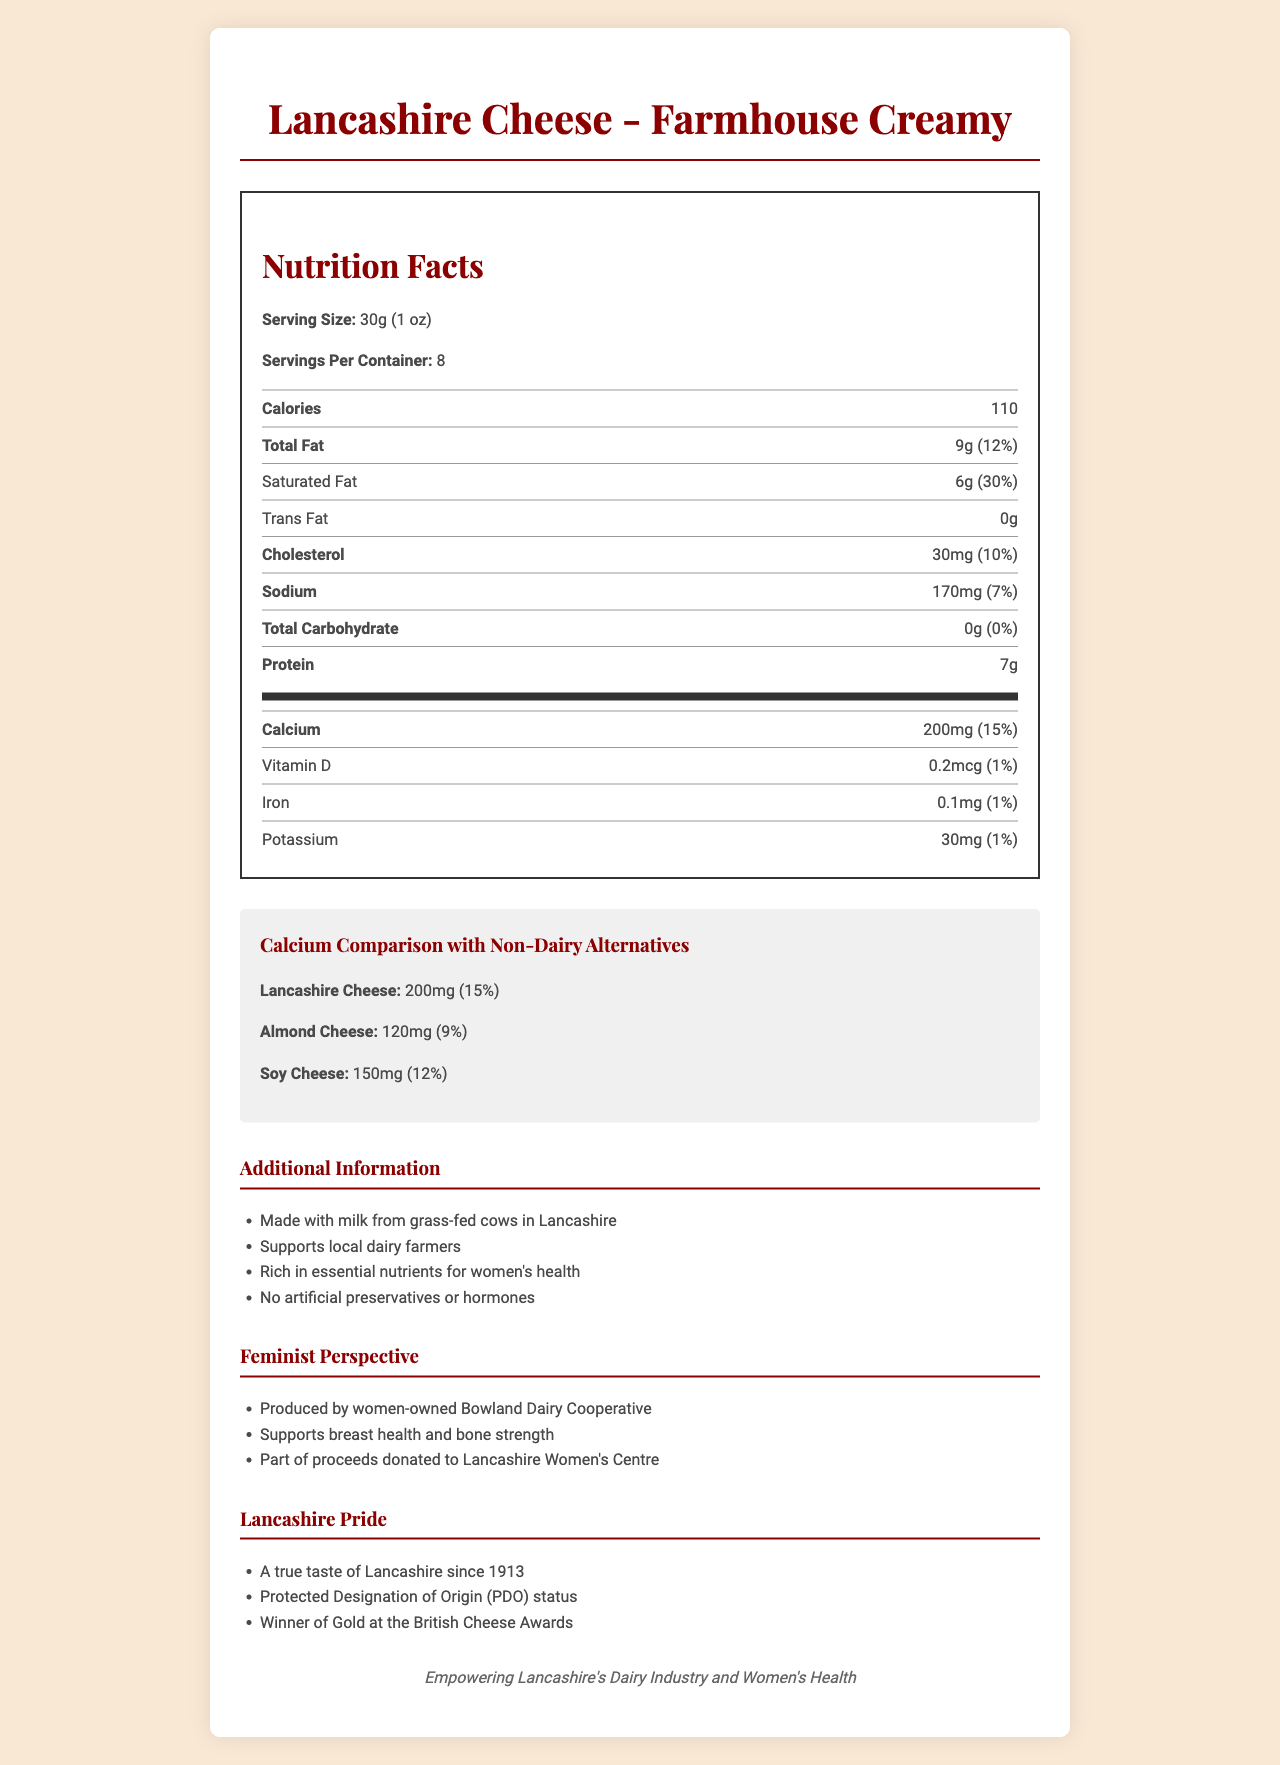what is the serving size for Lancashire Cheese - Farmhouse Creamy? The serving size is stated directly in the Nutritional Facts section as 30g (1 oz).
Answer: 30g (1 oz) how many servings per container does the Lancashire cheese have? The label mentions that there are 8 servings per container.
Answer: 8 how many calories are in one serving of Lancashire cheese? The calorie content per serving is listed as 110.
Answer: 110 what is the saturated fat content in one serving of Lancashire Cheese? The saturated fat content is stated as 6g which is 30% of the daily value.
Answer: 6g (30%) how much calcium does one serving of Lancashire Cheese provide? The calcium content for one serving is 200mg, which is 15% of the daily value.
Answer: 200mg (15%) how does the calcium content in Lancashire Cheese compare to Almond Cheese? A. 50mg more B. 80mg more C. 50mg less D. 80mg less Lancashire Cheese has 200mg of calcium, and Almond Cheese has 120mg. The difference is 80mg more in Lancashire Cheese.
Answer: B what is the amount of protein per serving of Lancashire Cheese? The protein content is listed as 7g per serving in the Nutritional Facts section.
Answer: 7g does Lancashire Cheese contain any trans fat? The label clearly states that the trans fat content is 0g.
Answer: No what is the primary benefit of this cheese from a feminist perspective? A. Women-owned cooperative B. High protein content C. Low fat D. Supports local pride One of the feminist perspectives mentioned is that the cheese is produced by a women-owned Bowland Dairy Cooperative.
Answer: A is the cheese made with artificial preservatives or hormones? The additional information lists that the cheese contains no artificial preservatives or hormones.
Answer: No can we determine the exact amount of Vitamin D in a serving of Lancashire Cheese from the label? The label specifies that there is 0.2mcg of Vitamin D per serving.
Answer: Yes what is the main idea of the document? The document includes the nutritional facts, calcium comparisons with non-dairy alternatives, additional benefits, feminist angles, and highlights local pride in Lancashire Cheese.
Answer: The document provides detailed nutritional information about Lancashire Cheese - Farmhouse Creamy, comparisons with non-dairy alternatives, additional health benefits, feminist values, and local pride. how much iron does one serving of Lancashire Cheese provide? The iron content per serving is listed as 0.1mg, which is 1% of the daily value.
Answer: 0.1mg (1%) what is the significance of the cheese having a Protected Designation of Origin (PDO)? The document does not provide an explanation for the significance of the cheese having Protected Designation of Origin (PDO) status.
Answer: Cannot be determined how much cholesterol does one serving of Lancashire Cheese contain? A. 10mg B. 20mg C. 30mg D. 40mg The label lists the cholesterol content as 30mg per serving.
Answer: C is the Lancashire cheese made from the milk of grass-fed cows? The additional information indicates that the cheese is made from milk from grass-fed cows in Lancashire.
Answer: Yes 